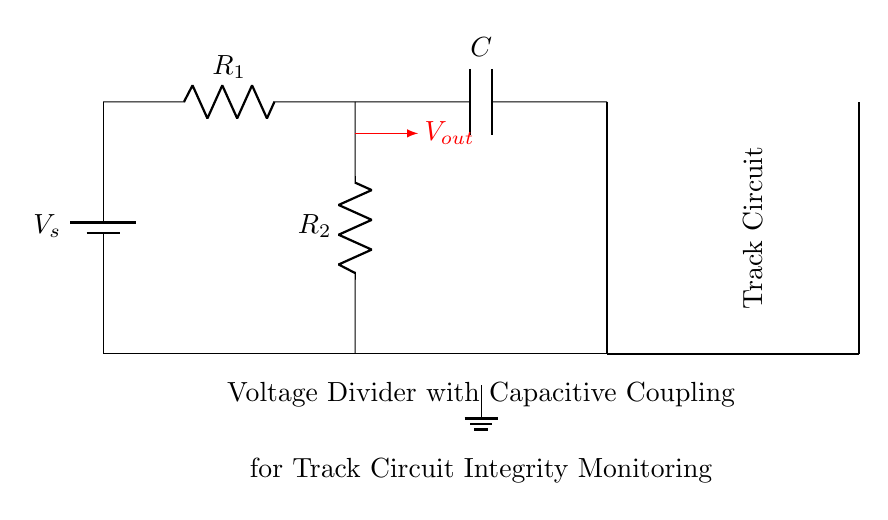What is the type of power supply in this circuit? The power supply is a battery, indicated by the symbol in the circuit.
Answer: Battery What is the function of the capacitor in this circuit? The capacitor serves to couple the voltage changes across the track circuit while blocking DC components, allowing AC signals to pass through for monitoring purposes.
Answer: Coupling What is the output voltage label in the circuit? The output voltage is shown as V out, which is the point where the voltage is measured after the resistors and capacitor.
Answer: V out Which components are involved in the voltage divider? The voltage divider is constructed using two resistors, R one and R two, which reduce the voltage.
Answer: R one and R two How many total components are there in the circuit? There are four main components in the circuit: one battery, two resistors, and one capacitor.
Answer: Four What role do R one and R two play together in this circuit? R one and R two form a voltage divider that determines the output voltage based on their values, affecting the voltage that appears across the capacitor.
Answer: Voltage divider What does the thick line represent in the diagram connecting to the track circuit? The thick line symbolizes the track circuit, indicating the pathway through which the voltage will relay the condition of the track monitoring.
Answer: Track circuit 